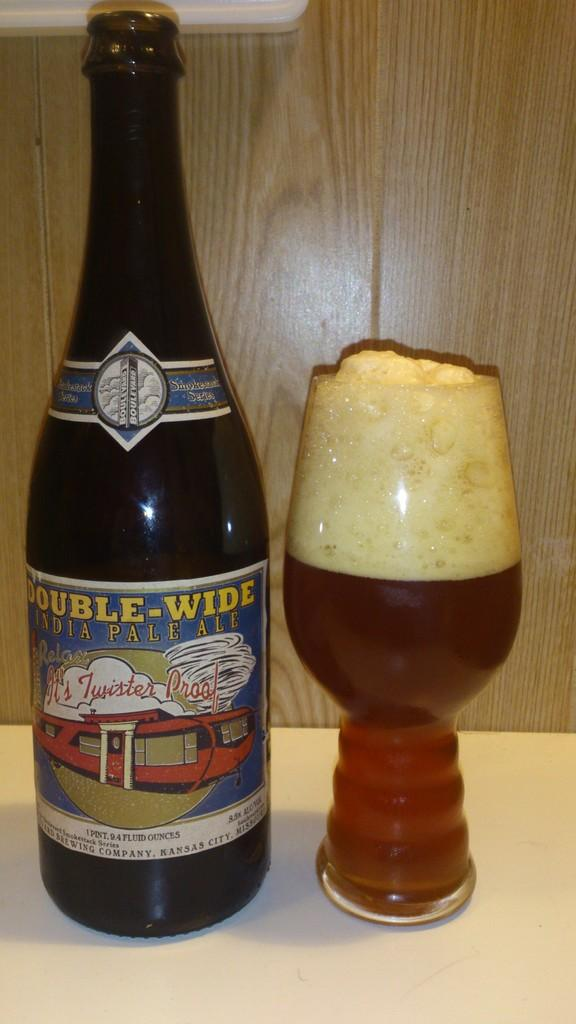Provide a one-sentence caption for the provided image. A bottle of Double-Wide India pale ale sits next to a glass of beer. 